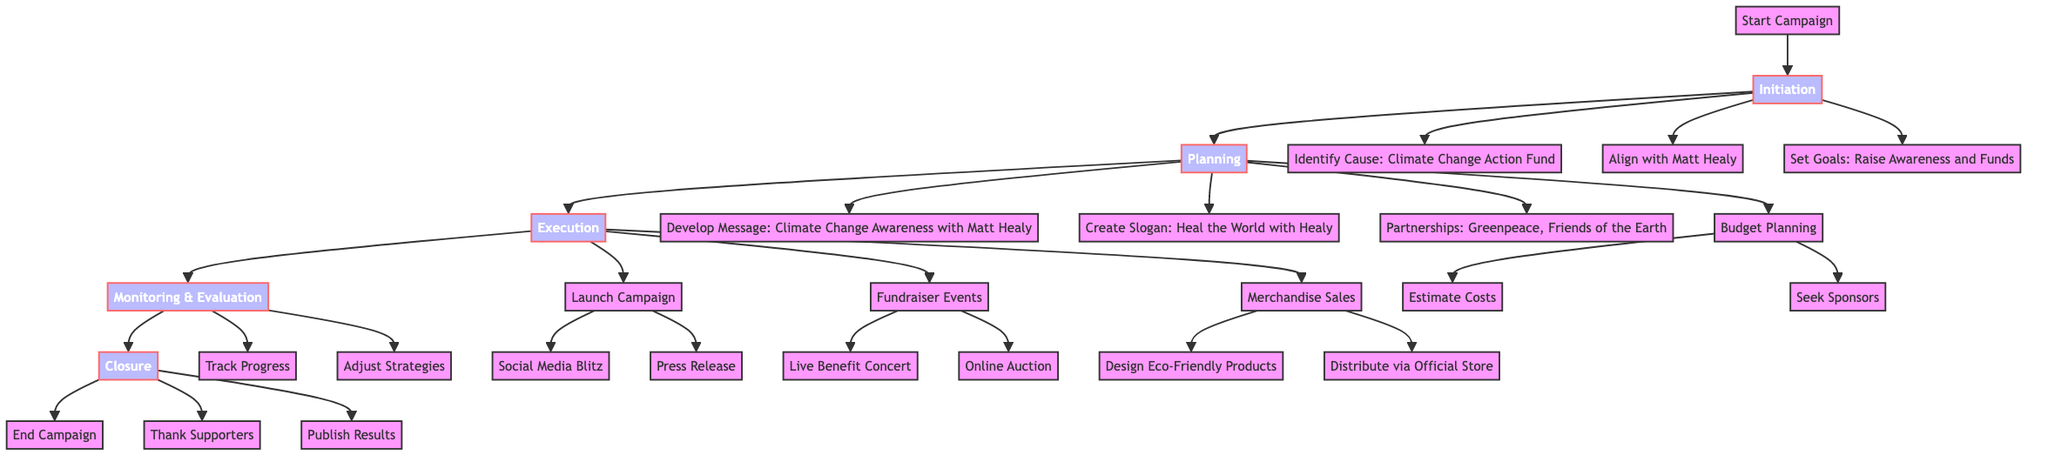What is the identified cause of the campaign? The diagram specifies "Climate Change Action Fund" as the identified cause during the Initiation phase.
Answer: Climate Change Action Fund How many partnerships are mentioned in the Planning phase? The diagram lists two partnerships (Greenpeace and Friends of the Earth) under the Planning phase.
Answer: 2 What slogan was created for the campaign? The slogan created for the campaign, as described in the Planning phase, is "Heal the World with Healy."
Answer: Heal the World with Healy Which social media platforms are included in the campaign launch? The diagram highlights three platforms: Instagram, Twitter, and TikTok, under the Launch Campaign.
Answer: Instagram, Twitter, TikTok What type of event is planned as part of fundraising? The diagram indicates that a "Live Benefit Concert Featuring The 1975" is planned as a fundraiser event.
Answer: Live Benefit Concert What is the final step in the closure phase of the campaign? The diagram shows that the last step is to "Publish Results," indicating the completion of the campaign.
Answer: Publish Results How does the campaign adjust its strategies? According to the diagram, the campaign adjusts its strategies "Based on Real-Time Feedback" during the Monitoring and Evaluation phase.
Answer: Based on Real-Time Feedback Which merchandise product types are designed as part of the campaign? The diagram states that "T-Shirts" and "Reusable Bags" are the types of eco-friendly products designed for merchandise sales.
Answer: T-Shirts, Reusable Bags What is the purpose of the press release in the Execution phase? The diagram specifies that the press release aims to reach "Major News Outlets" as part of the campaign execution.
Answer: Major News Outlets 